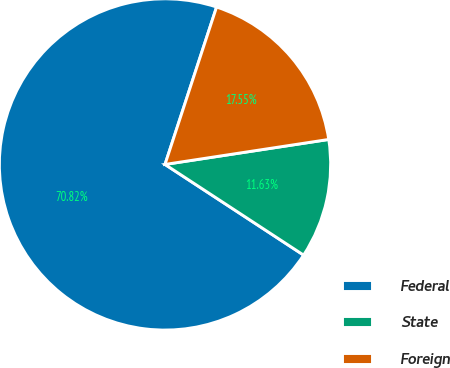Convert chart to OTSL. <chart><loc_0><loc_0><loc_500><loc_500><pie_chart><fcel>Federal<fcel>State<fcel>Foreign<nl><fcel>70.82%<fcel>11.63%<fcel>17.55%<nl></chart> 